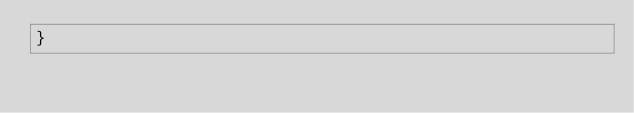Convert code to text. <code><loc_0><loc_0><loc_500><loc_500><_Java_>}
</code> 